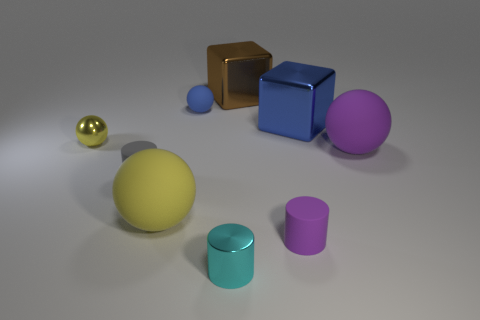How many things are either cyan metallic cylinders or big blue metallic cylinders?
Provide a succinct answer. 1. Is the gray object the same shape as the blue metallic thing?
Offer a terse response. No. Is the size of the blue object that is on the left side of the brown block the same as the matte ball on the right side of the cyan metal cylinder?
Make the answer very short. No. What is the material of the tiny cylinder that is both left of the small purple thing and on the right side of the tiny gray matte cylinder?
Keep it short and to the point. Metal. Is there anything else that is the same color as the tiny matte ball?
Offer a very short reply. Yes. Are there fewer tiny cyan objects that are to the left of the metal cylinder than large blue blocks?
Keep it short and to the point. Yes. Is the number of yellow matte things greater than the number of green blocks?
Provide a short and direct response. Yes. Are there any large brown metallic objects that are behind the small object that is in front of the tiny rubber object to the right of the large brown shiny block?
Offer a very short reply. Yes. What number of other things are the same size as the yellow matte object?
Keep it short and to the point. 3. Are there any tiny yellow shiny spheres on the left side of the large yellow ball?
Provide a short and direct response. Yes. 